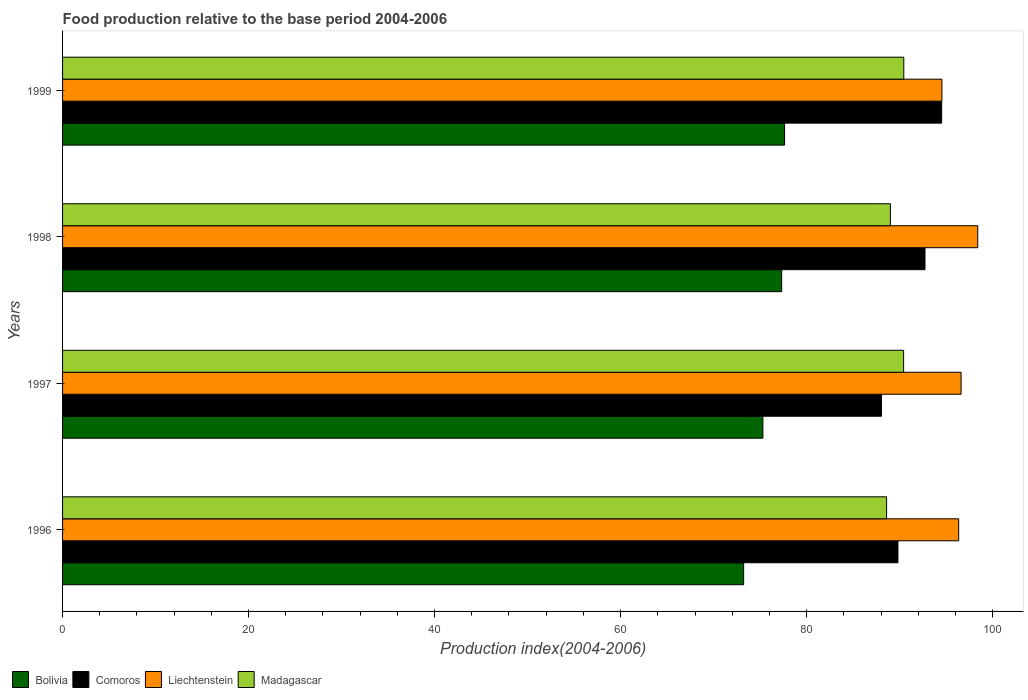Are the number of bars per tick equal to the number of legend labels?
Your answer should be compact. Yes. How many bars are there on the 2nd tick from the top?
Keep it short and to the point. 4. What is the food production index in Madagascar in 1999?
Your answer should be compact. 90.45. Across all years, what is the maximum food production index in Bolivia?
Make the answer very short. 77.63. Across all years, what is the minimum food production index in Madagascar?
Provide a short and direct response. 88.6. In which year was the food production index in Comoros minimum?
Keep it short and to the point. 1997. What is the total food production index in Bolivia in the graph?
Ensure brevity in your answer.  303.48. What is the difference between the food production index in Comoros in 1998 and that in 1999?
Offer a terse response. -1.79. What is the difference between the food production index in Madagascar in 1997 and the food production index in Liechtenstein in 1999?
Keep it short and to the point. -4.12. What is the average food production index in Comoros per year?
Make the answer very short. 91.28. In the year 1996, what is the difference between the food production index in Bolivia and food production index in Madagascar?
Keep it short and to the point. -15.37. What is the ratio of the food production index in Liechtenstein in 1997 to that in 1998?
Your answer should be compact. 0.98. What is the difference between the highest and the second highest food production index in Bolivia?
Offer a terse response. 0.31. What is the difference between the highest and the lowest food production index in Bolivia?
Give a very brief answer. 4.4. In how many years, is the food production index in Bolivia greater than the average food production index in Bolivia taken over all years?
Your response must be concise. 2. What does the 3rd bar from the top in 1997 represents?
Make the answer very short. Comoros. What does the 2nd bar from the bottom in 1999 represents?
Make the answer very short. Comoros. Is it the case that in every year, the sum of the food production index in Liechtenstein and food production index in Comoros is greater than the food production index in Madagascar?
Your answer should be compact. Yes. Are all the bars in the graph horizontal?
Your answer should be compact. Yes. Are the values on the major ticks of X-axis written in scientific E-notation?
Keep it short and to the point. No. How many legend labels are there?
Offer a very short reply. 4. How are the legend labels stacked?
Give a very brief answer. Horizontal. What is the title of the graph?
Your response must be concise. Food production relative to the base period 2004-2006. What is the label or title of the X-axis?
Keep it short and to the point. Production index(2004-2006). What is the Production index(2004-2006) of Bolivia in 1996?
Your response must be concise. 73.23. What is the Production index(2004-2006) of Comoros in 1996?
Ensure brevity in your answer.  89.82. What is the Production index(2004-2006) in Liechtenstein in 1996?
Offer a terse response. 96.35. What is the Production index(2004-2006) of Madagascar in 1996?
Your response must be concise. 88.6. What is the Production index(2004-2006) of Bolivia in 1997?
Offer a terse response. 75.3. What is the Production index(2004-2006) of Comoros in 1997?
Ensure brevity in your answer.  88.05. What is the Production index(2004-2006) in Liechtenstein in 1997?
Keep it short and to the point. 96.61. What is the Production index(2004-2006) in Madagascar in 1997?
Offer a terse response. 90.43. What is the Production index(2004-2006) in Bolivia in 1998?
Give a very brief answer. 77.32. What is the Production index(2004-2006) in Comoros in 1998?
Ensure brevity in your answer.  92.73. What is the Production index(2004-2006) of Liechtenstein in 1998?
Provide a succinct answer. 98.4. What is the Production index(2004-2006) in Madagascar in 1998?
Make the answer very short. 89.01. What is the Production index(2004-2006) of Bolivia in 1999?
Ensure brevity in your answer.  77.63. What is the Production index(2004-2006) of Comoros in 1999?
Keep it short and to the point. 94.52. What is the Production index(2004-2006) in Liechtenstein in 1999?
Offer a very short reply. 94.55. What is the Production index(2004-2006) in Madagascar in 1999?
Ensure brevity in your answer.  90.45. Across all years, what is the maximum Production index(2004-2006) in Bolivia?
Your answer should be compact. 77.63. Across all years, what is the maximum Production index(2004-2006) of Comoros?
Your answer should be very brief. 94.52. Across all years, what is the maximum Production index(2004-2006) of Liechtenstein?
Your answer should be very brief. 98.4. Across all years, what is the maximum Production index(2004-2006) in Madagascar?
Your answer should be very brief. 90.45. Across all years, what is the minimum Production index(2004-2006) in Bolivia?
Your response must be concise. 73.23. Across all years, what is the minimum Production index(2004-2006) in Comoros?
Provide a succinct answer. 88.05. Across all years, what is the minimum Production index(2004-2006) in Liechtenstein?
Offer a very short reply. 94.55. Across all years, what is the minimum Production index(2004-2006) in Madagascar?
Provide a succinct answer. 88.6. What is the total Production index(2004-2006) of Bolivia in the graph?
Provide a short and direct response. 303.48. What is the total Production index(2004-2006) in Comoros in the graph?
Provide a short and direct response. 365.12. What is the total Production index(2004-2006) in Liechtenstein in the graph?
Your response must be concise. 385.91. What is the total Production index(2004-2006) of Madagascar in the graph?
Your response must be concise. 358.49. What is the difference between the Production index(2004-2006) of Bolivia in 1996 and that in 1997?
Provide a succinct answer. -2.07. What is the difference between the Production index(2004-2006) in Comoros in 1996 and that in 1997?
Offer a terse response. 1.77. What is the difference between the Production index(2004-2006) of Liechtenstein in 1996 and that in 1997?
Keep it short and to the point. -0.26. What is the difference between the Production index(2004-2006) in Madagascar in 1996 and that in 1997?
Give a very brief answer. -1.83. What is the difference between the Production index(2004-2006) in Bolivia in 1996 and that in 1998?
Your answer should be very brief. -4.09. What is the difference between the Production index(2004-2006) in Comoros in 1996 and that in 1998?
Make the answer very short. -2.91. What is the difference between the Production index(2004-2006) of Liechtenstein in 1996 and that in 1998?
Provide a succinct answer. -2.05. What is the difference between the Production index(2004-2006) of Madagascar in 1996 and that in 1998?
Ensure brevity in your answer.  -0.41. What is the difference between the Production index(2004-2006) of Bolivia in 1996 and that in 1999?
Ensure brevity in your answer.  -4.4. What is the difference between the Production index(2004-2006) in Comoros in 1996 and that in 1999?
Your answer should be compact. -4.7. What is the difference between the Production index(2004-2006) in Madagascar in 1996 and that in 1999?
Provide a short and direct response. -1.85. What is the difference between the Production index(2004-2006) of Bolivia in 1997 and that in 1998?
Provide a succinct answer. -2.02. What is the difference between the Production index(2004-2006) in Comoros in 1997 and that in 1998?
Your answer should be very brief. -4.68. What is the difference between the Production index(2004-2006) in Liechtenstein in 1997 and that in 1998?
Make the answer very short. -1.79. What is the difference between the Production index(2004-2006) in Madagascar in 1997 and that in 1998?
Your answer should be very brief. 1.42. What is the difference between the Production index(2004-2006) of Bolivia in 1997 and that in 1999?
Your response must be concise. -2.33. What is the difference between the Production index(2004-2006) of Comoros in 1997 and that in 1999?
Ensure brevity in your answer.  -6.47. What is the difference between the Production index(2004-2006) in Liechtenstein in 1997 and that in 1999?
Give a very brief answer. 2.06. What is the difference between the Production index(2004-2006) of Madagascar in 1997 and that in 1999?
Provide a short and direct response. -0.02. What is the difference between the Production index(2004-2006) of Bolivia in 1998 and that in 1999?
Make the answer very short. -0.31. What is the difference between the Production index(2004-2006) in Comoros in 1998 and that in 1999?
Ensure brevity in your answer.  -1.79. What is the difference between the Production index(2004-2006) in Liechtenstein in 1998 and that in 1999?
Make the answer very short. 3.85. What is the difference between the Production index(2004-2006) in Madagascar in 1998 and that in 1999?
Offer a terse response. -1.44. What is the difference between the Production index(2004-2006) of Bolivia in 1996 and the Production index(2004-2006) of Comoros in 1997?
Your response must be concise. -14.82. What is the difference between the Production index(2004-2006) of Bolivia in 1996 and the Production index(2004-2006) of Liechtenstein in 1997?
Ensure brevity in your answer.  -23.38. What is the difference between the Production index(2004-2006) in Bolivia in 1996 and the Production index(2004-2006) in Madagascar in 1997?
Offer a terse response. -17.2. What is the difference between the Production index(2004-2006) of Comoros in 1996 and the Production index(2004-2006) of Liechtenstein in 1997?
Give a very brief answer. -6.79. What is the difference between the Production index(2004-2006) in Comoros in 1996 and the Production index(2004-2006) in Madagascar in 1997?
Keep it short and to the point. -0.61. What is the difference between the Production index(2004-2006) in Liechtenstein in 1996 and the Production index(2004-2006) in Madagascar in 1997?
Offer a very short reply. 5.92. What is the difference between the Production index(2004-2006) of Bolivia in 1996 and the Production index(2004-2006) of Comoros in 1998?
Make the answer very short. -19.5. What is the difference between the Production index(2004-2006) in Bolivia in 1996 and the Production index(2004-2006) in Liechtenstein in 1998?
Your response must be concise. -25.17. What is the difference between the Production index(2004-2006) in Bolivia in 1996 and the Production index(2004-2006) in Madagascar in 1998?
Provide a short and direct response. -15.78. What is the difference between the Production index(2004-2006) in Comoros in 1996 and the Production index(2004-2006) in Liechtenstein in 1998?
Provide a succinct answer. -8.58. What is the difference between the Production index(2004-2006) in Comoros in 1996 and the Production index(2004-2006) in Madagascar in 1998?
Your answer should be compact. 0.81. What is the difference between the Production index(2004-2006) in Liechtenstein in 1996 and the Production index(2004-2006) in Madagascar in 1998?
Provide a short and direct response. 7.34. What is the difference between the Production index(2004-2006) in Bolivia in 1996 and the Production index(2004-2006) in Comoros in 1999?
Ensure brevity in your answer.  -21.29. What is the difference between the Production index(2004-2006) in Bolivia in 1996 and the Production index(2004-2006) in Liechtenstein in 1999?
Your answer should be very brief. -21.32. What is the difference between the Production index(2004-2006) of Bolivia in 1996 and the Production index(2004-2006) of Madagascar in 1999?
Your answer should be compact. -17.22. What is the difference between the Production index(2004-2006) in Comoros in 1996 and the Production index(2004-2006) in Liechtenstein in 1999?
Your response must be concise. -4.73. What is the difference between the Production index(2004-2006) in Comoros in 1996 and the Production index(2004-2006) in Madagascar in 1999?
Your response must be concise. -0.63. What is the difference between the Production index(2004-2006) in Liechtenstein in 1996 and the Production index(2004-2006) in Madagascar in 1999?
Ensure brevity in your answer.  5.9. What is the difference between the Production index(2004-2006) of Bolivia in 1997 and the Production index(2004-2006) of Comoros in 1998?
Your answer should be compact. -17.43. What is the difference between the Production index(2004-2006) of Bolivia in 1997 and the Production index(2004-2006) of Liechtenstein in 1998?
Your answer should be very brief. -23.1. What is the difference between the Production index(2004-2006) of Bolivia in 1997 and the Production index(2004-2006) of Madagascar in 1998?
Provide a short and direct response. -13.71. What is the difference between the Production index(2004-2006) in Comoros in 1997 and the Production index(2004-2006) in Liechtenstein in 1998?
Provide a short and direct response. -10.35. What is the difference between the Production index(2004-2006) of Comoros in 1997 and the Production index(2004-2006) of Madagascar in 1998?
Make the answer very short. -0.96. What is the difference between the Production index(2004-2006) of Liechtenstein in 1997 and the Production index(2004-2006) of Madagascar in 1998?
Your answer should be compact. 7.6. What is the difference between the Production index(2004-2006) in Bolivia in 1997 and the Production index(2004-2006) in Comoros in 1999?
Your answer should be very brief. -19.22. What is the difference between the Production index(2004-2006) of Bolivia in 1997 and the Production index(2004-2006) of Liechtenstein in 1999?
Give a very brief answer. -19.25. What is the difference between the Production index(2004-2006) in Bolivia in 1997 and the Production index(2004-2006) in Madagascar in 1999?
Ensure brevity in your answer.  -15.15. What is the difference between the Production index(2004-2006) of Comoros in 1997 and the Production index(2004-2006) of Liechtenstein in 1999?
Provide a succinct answer. -6.5. What is the difference between the Production index(2004-2006) in Liechtenstein in 1997 and the Production index(2004-2006) in Madagascar in 1999?
Keep it short and to the point. 6.16. What is the difference between the Production index(2004-2006) of Bolivia in 1998 and the Production index(2004-2006) of Comoros in 1999?
Ensure brevity in your answer.  -17.2. What is the difference between the Production index(2004-2006) in Bolivia in 1998 and the Production index(2004-2006) in Liechtenstein in 1999?
Offer a very short reply. -17.23. What is the difference between the Production index(2004-2006) in Bolivia in 1998 and the Production index(2004-2006) in Madagascar in 1999?
Keep it short and to the point. -13.13. What is the difference between the Production index(2004-2006) in Comoros in 1998 and the Production index(2004-2006) in Liechtenstein in 1999?
Give a very brief answer. -1.82. What is the difference between the Production index(2004-2006) in Comoros in 1998 and the Production index(2004-2006) in Madagascar in 1999?
Provide a succinct answer. 2.28. What is the difference between the Production index(2004-2006) in Liechtenstein in 1998 and the Production index(2004-2006) in Madagascar in 1999?
Offer a very short reply. 7.95. What is the average Production index(2004-2006) in Bolivia per year?
Give a very brief answer. 75.87. What is the average Production index(2004-2006) of Comoros per year?
Provide a succinct answer. 91.28. What is the average Production index(2004-2006) of Liechtenstein per year?
Offer a very short reply. 96.48. What is the average Production index(2004-2006) in Madagascar per year?
Your answer should be very brief. 89.62. In the year 1996, what is the difference between the Production index(2004-2006) in Bolivia and Production index(2004-2006) in Comoros?
Your answer should be compact. -16.59. In the year 1996, what is the difference between the Production index(2004-2006) in Bolivia and Production index(2004-2006) in Liechtenstein?
Your response must be concise. -23.12. In the year 1996, what is the difference between the Production index(2004-2006) in Bolivia and Production index(2004-2006) in Madagascar?
Provide a short and direct response. -15.37. In the year 1996, what is the difference between the Production index(2004-2006) in Comoros and Production index(2004-2006) in Liechtenstein?
Make the answer very short. -6.53. In the year 1996, what is the difference between the Production index(2004-2006) of Comoros and Production index(2004-2006) of Madagascar?
Offer a terse response. 1.22. In the year 1996, what is the difference between the Production index(2004-2006) of Liechtenstein and Production index(2004-2006) of Madagascar?
Provide a short and direct response. 7.75. In the year 1997, what is the difference between the Production index(2004-2006) of Bolivia and Production index(2004-2006) of Comoros?
Your response must be concise. -12.75. In the year 1997, what is the difference between the Production index(2004-2006) of Bolivia and Production index(2004-2006) of Liechtenstein?
Offer a terse response. -21.31. In the year 1997, what is the difference between the Production index(2004-2006) of Bolivia and Production index(2004-2006) of Madagascar?
Offer a terse response. -15.13. In the year 1997, what is the difference between the Production index(2004-2006) of Comoros and Production index(2004-2006) of Liechtenstein?
Your response must be concise. -8.56. In the year 1997, what is the difference between the Production index(2004-2006) of Comoros and Production index(2004-2006) of Madagascar?
Your answer should be very brief. -2.38. In the year 1997, what is the difference between the Production index(2004-2006) in Liechtenstein and Production index(2004-2006) in Madagascar?
Make the answer very short. 6.18. In the year 1998, what is the difference between the Production index(2004-2006) in Bolivia and Production index(2004-2006) in Comoros?
Offer a terse response. -15.41. In the year 1998, what is the difference between the Production index(2004-2006) of Bolivia and Production index(2004-2006) of Liechtenstein?
Make the answer very short. -21.08. In the year 1998, what is the difference between the Production index(2004-2006) in Bolivia and Production index(2004-2006) in Madagascar?
Make the answer very short. -11.69. In the year 1998, what is the difference between the Production index(2004-2006) of Comoros and Production index(2004-2006) of Liechtenstein?
Keep it short and to the point. -5.67. In the year 1998, what is the difference between the Production index(2004-2006) of Comoros and Production index(2004-2006) of Madagascar?
Your answer should be very brief. 3.72. In the year 1998, what is the difference between the Production index(2004-2006) of Liechtenstein and Production index(2004-2006) of Madagascar?
Provide a short and direct response. 9.39. In the year 1999, what is the difference between the Production index(2004-2006) in Bolivia and Production index(2004-2006) in Comoros?
Provide a succinct answer. -16.89. In the year 1999, what is the difference between the Production index(2004-2006) in Bolivia and Production index(2004-2006) in Liechtenstein?
Provide a short and direct response. -16.92. In the year 1999, what is the difference between the Production index(2004-2006) of Bolivia and Production index(2004-2006) of Madagascar?
Keep it short and to the point. -12.82. In the year 1999, what is the difference between the Production index(2004-2006) in Comoros and Production index(2004-2006) in Liechtenstein?
Offer a very short reply. -0.03. In the year 1999, what is the difference between the Production index(2004-2006) of Comoros and Production index(2004-2006) of Madagascar?
Ensure brevity in your answer.  4.07. What is the ratio of the Production index(2004-2006) of Bolivia in 1996 to that in 1997?
Your response must be concise. 0.97. What is the ratio of the Production index(2004-2006) in Comoros in 1996 to that in 1997?
Your answer should be compact. 1.02. What is the ratio of the Production index(2004-2006) of Liechtenstein in 1996 to that in 1997?
Give a very brief answer. 1. What is the ratio of the Production index(2004-2006) in Madagascar in 1996 to that in 1997?
Your response must be concise. 0.98. What is the ratio of the Production index(2004-2006) in Bolivia in 1996 to that in 1998?
Make the answer very short. 0.95. What is the ratio of the Production index(2004-2006) of Comoros in 1996 to that in 1998?
Provide a succinct answer. 0.97. What is the ratio of the Production index(2004-2006) in Liechtenstein in 1996 to that in 1998?
Give a very brief answer. 0.98. What is the ratio of the Production index(2004-2006) in Madagascar in 1996 to that in 1998?
Provide a succinct answer. 1. What is the ratio of the Production index(2004-2006) in Bolivia in 1996 to that in 1999?
Offer a very short reply. 0.94. What is the ratio of the Production index(2004-2006) of Comoros in 1996 to that in 1999?
Ensure brevity in your answer.  0.95. What is the ratio of the Production index(2004-2006) in Liechtenstein in 1996 to that in 1999?
Your response must be concise. 1.02. What is the ratio of the Production index(2004-2006) of Madagascar in 1996 to that in 1999?
Your answer should be very brief. 0.98. What is the ratio of the Production index(2004-2006) in Bolivia in 1997 to that in 1998?
Make the answer very short. 0.97. What is the ratio of the Production index(2004-2006) of Comoros in 1997 to that in 1998?
Ensure brevity in your answer.  0.95. What is the ratio of the Production index(2004-2006) in Liechtenstein in 1997 to that in 1998?
Ensure brevity in your answer.  0.98. What is the ratio of the Production index(2004-2006) in Madagascar in 1997 to that in 1998?
Offer a very short reply. 1.02. What is the ratio of the Production index(2004-2006) of Comoros in 1997 to that in 1999?
Keep it short and to the point. 0.93. What is the ratio of the Production index(2004-2006) of Liechtenstein in 1997 to that in 1999?
Provide a short and direct response. 1.02. What is the ratio of the Production index(2004-2006) in Madagascar in 1997 to that in 1999?
Make the answer very short. 1. What is the ratio of the Production index(2004-2006) in Comoros in 1998 to that in 1999?
Ensure brevity in your answer.  0.98. What is the ratio of the Production index(2004-2006) of Liechtenstein in 1998 to that in 1999?
Make the answer very short. 1.04. What is the ratio of the Production index(2004-2006) of Madagascar in 1998 to that in 1999?
Offer a very short reply. 0.98. What is the difference between the highest and the second highest Production index(2004-2006) of Bolivia?
Provide a succinct answer. 0.31. What is the difference between the highest and the second highest Production index(2004-2006) of Comoros?
Provide a short and direct response. 1.79. What is the difference between the highest and the second highest Production index(2004-2006) in Liechtenstein?
Your response must be concise. 1.79. What is the difference between the highest and the second highest Production index(2004-2006) in Madagascar?
Offer a very short reply. 0.02. What is the difference between the highest and the lowest Production index(2004-2006) in Bolivia?
Offer a terse response. 4.4. What is the difference between the highest and the lowest Production index(2004-2006) of Comoros?
Your answer should be very brief. 6.47. What is the difference between the highest and the lowest Production index(2004-2006) of Liechtenstein?
Your answer should be compact. 3.85. What is the difference between the highest and the lowest Production index(2004-2006) of Madagascar?
Keep it short and to the point. 1.85. 